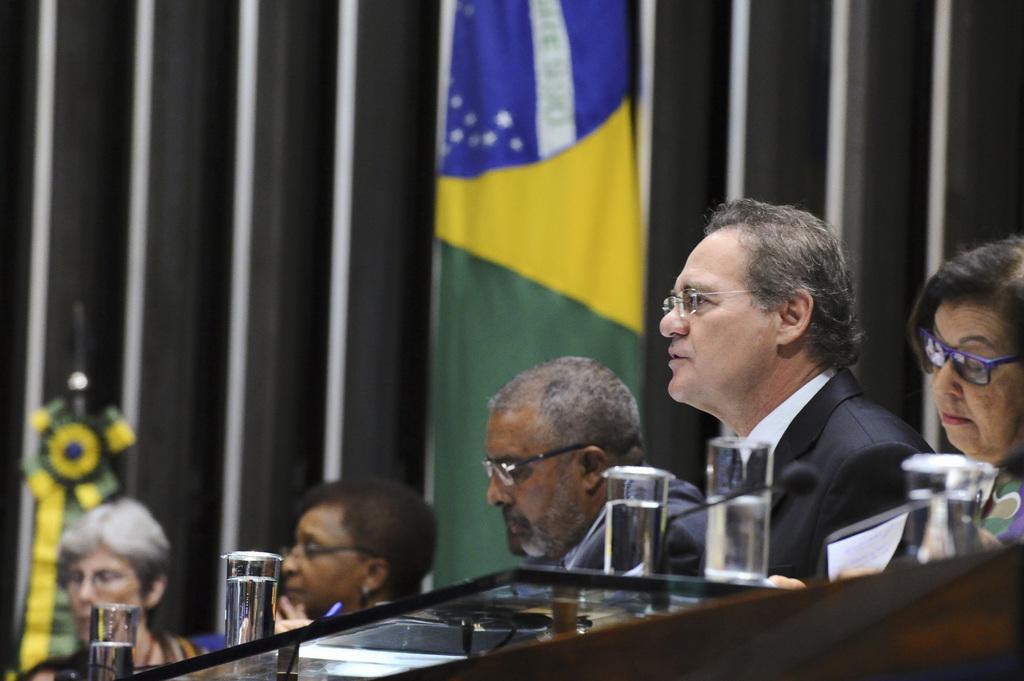Could you give a brief overview of what you see in this image? In this image there are people. Before them there is a table having glasses. Behind them there is a flag. Left side there is an object. Background there is a wall. 